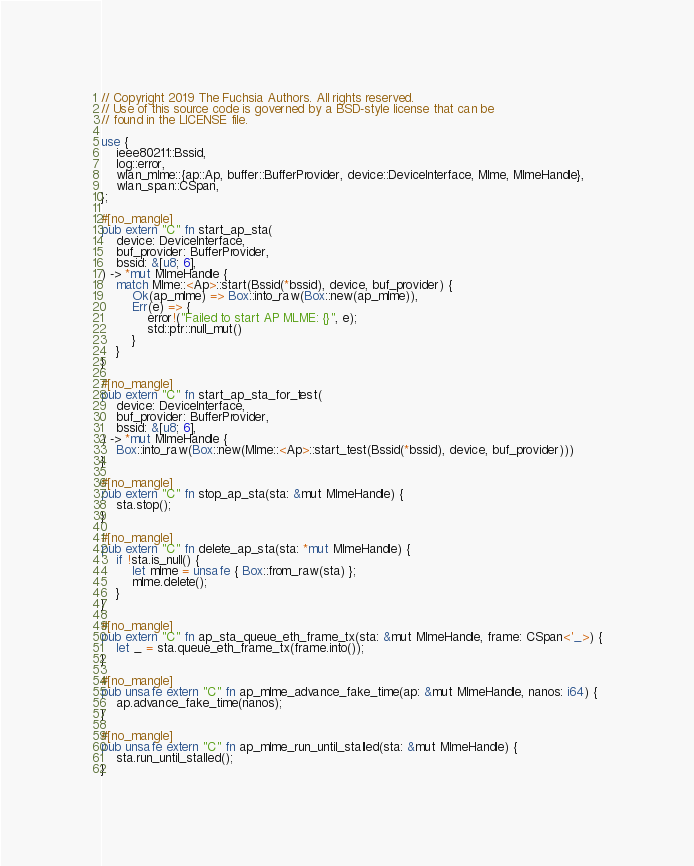Convert code to text. <code><loc_0><loc_0><loc_500><loc_500><_Rust_>// Copyright 2019 The Fuchsia Authors. All rights reserved.
// Use of this source code is governed by a BSD-style license that can be
// found in the LICENSE file.

use {
    ieee80211::Bssid,
    log::error,
    wlan_mlme::{ap::Ap, buffer::BufferProvider, device::DeviceInterface, Mlme, MlmeHandle},
    wlan_span::CSpan,
};

#[no_mangle]
pub extern "C" fn start_ap_sta(
    device: DeviceInterface,
    buf_provider: BufferProvider,
    bssid: &[u8; 6],
) -> *mut MlmeHandle {
    match Mlme::<Ap>::start(Bssid(*bssid), device, buf_provider) {
        Ok(ap_mlme) => Box::into_raw(Box::new(ap_mlme)),
        Err(e) => {
            error!("Failed to start AP MLME: {}", e);
            std::ptr::null_mut()
        }
    }
}

#[no_mangle]
pub extern "C" fn start_ap_sta_for_test(
    device: DeviceInterface,
    buf_provider: BufferProvider,
    bssid: &[u8; 6],
) -> *mut MlmeHandle {
    Box::into_raw(Box::new(Mlme::<Ap>::start_test(Bssid(*bssid), device, buf_provider)))
}

#[no_mangle]
pub extern "C" fn stop_ap_sta(sta: &mut MlmeHandle) {
    sta.stop();
}

#[no_mangle]
pub extern "C" fn delete_ap_sta(sta: *mut MlmeHandle) {
    if !sta.is_null() {
        let mlme = unsafe { Box::from_raw(sta) };
        mlme.delete();
    }
}

#[no_mangle]
pub extern "C" fn ap_sta_queue_eth_frame_tx(sta: &mut MlmeHandle, frame: CSpan<'_>) {
    let _ = sta.queue_eth_frame_tx(frame.into());
}

#[no_mangle]
pub unsafe extern "C" fn ap_mlme_advance_fake_time(ap: &mut MlmeHandle, nanos: i64) {
    ap.advance_fake_time(nanos);
}

#[no_mangle]
pub unsafe extern "C" fn ap_mlme_run_until_stalled(sta: &mut MlmeHandle) {
    sta.run_until_stalled();
}
</code> 